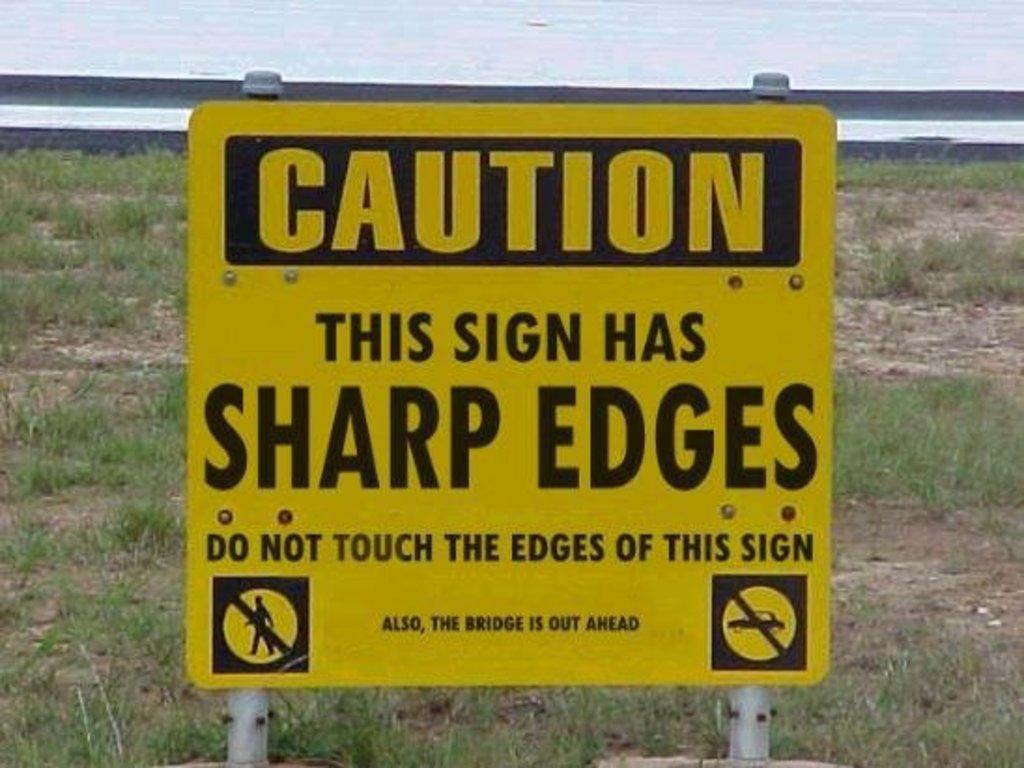<image>
Describe the image concisely. A sign reads Caution this sign has shard edges. 